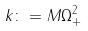<formula> <loc_0><loc_0><loc_500><loc_500>k \colon = M \Omega _ { + } ^ { 2 }</formula> 